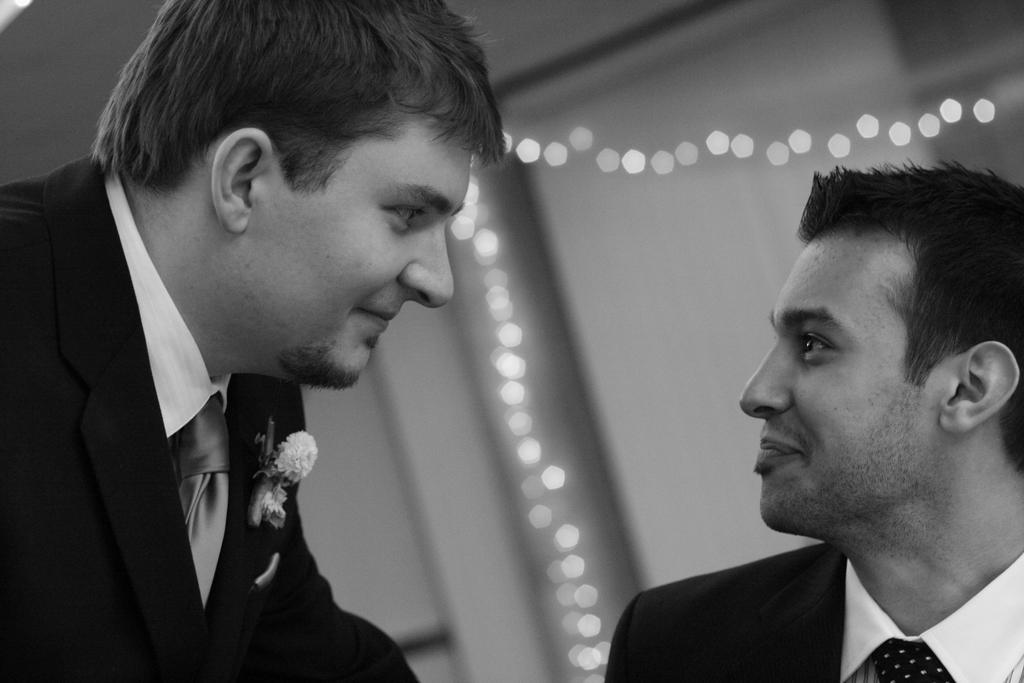What is the color scheme of the image? The image is black and white. How many people are in the image? There are two men in the image. What can be seen in the background of the image? There is a wall in the background of the image. Is there any source of light in the image? Yes, there is lighting near the wall. How many gloves can be seen on the wall in the image? There are no gloves present in the image. What is the mass of the step in the image? There is no step present in the image, so it is not possible to determine its mass. 